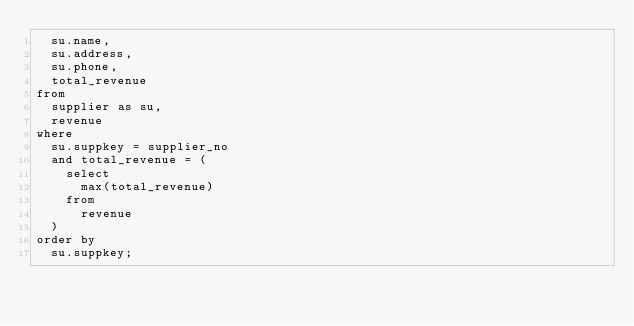Convert code to text. <code><loc_0><loc_0><loc_500><loc_500><_SQL_>	su.name,
	su.address,
	su.phone,
	total_revenue
from
	supplier as su,
	revenue
where
	su.suppkey = supplier_no
	and total_revenue = (
		select
			max(total_revenue)
		from
			revenue
	)
order by
	su.suppkey;
</code> 